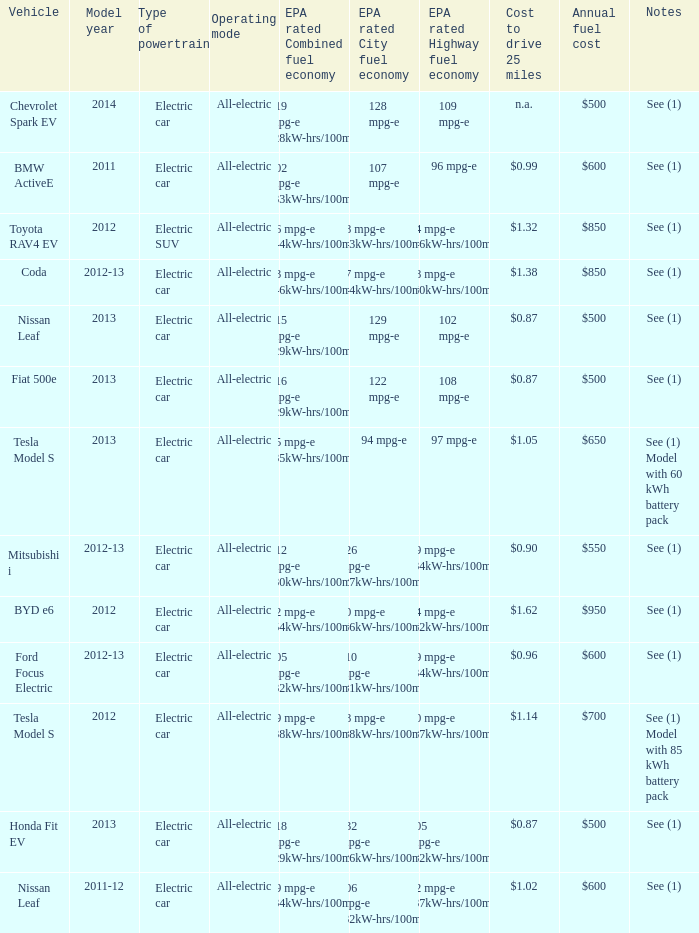What vehicle has an epa highway fuel economy of 109 mpg-e? Chevrolet Spark EV. 